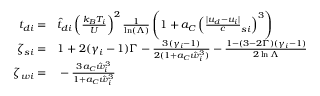<formula> <loc_0><loc_0><loc_500><loc_500>\begin{array} { r l } { { t _ { d i } } = } & \hat { t } _ { d i } \left ( \frac { k _ { B } T _ { i } } U \right ) ^ { 2 } \frac { 1 } \ln ( \Lambda ) } \left ( 1 + a _ { C } \left ( \frac { | { u _ { d } } - { u _ { i } } | } c _ { s i } \right ) ^ { 3 } \right ) } \\ { \zeta _ { s i } = } & 1 + 2 ( \gamma _ { i } - 1 ) \Gamma - \frac { 3 ( \gamma _ { i } - 1 ) } { 2 ( 1 + a _ { C } \hat { w } _ { i } ^ { 3 } ) } - \frac { 1 - ( 3 - 2 \Gamma ) ( \gamma _ { i } - 1 ) } { 2 \ln { \Lambda } } } \\ { \zeta _ { w i } = } & - \frac { 3 a _ { C } \hat { w } _ { i } ^ { 3 } } { 1 + a _ { C } \hat { w } _ { i } ^ { 3 } } } \end{array}</formula> 